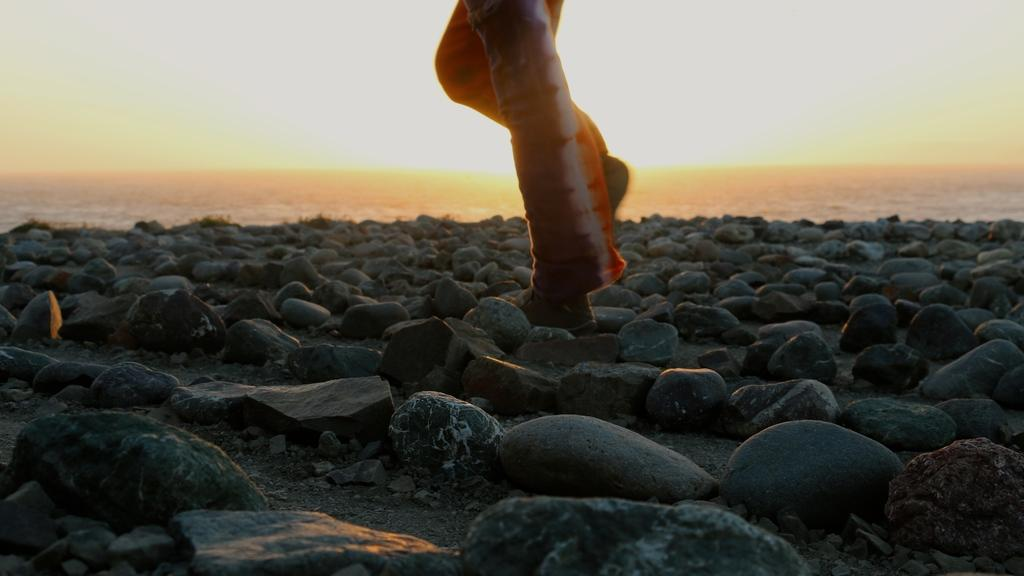What type of objects can be seen in the image? There are rocks in the image. What feature is present on the rocks? There are legs on the rocks. What can be seen in the distance behind the rocks? The background of the image appears to be the sea. What type of rice can be seen on the rocks in the image? There is no rice present in the image; it features rocks with legs in a sea background. 